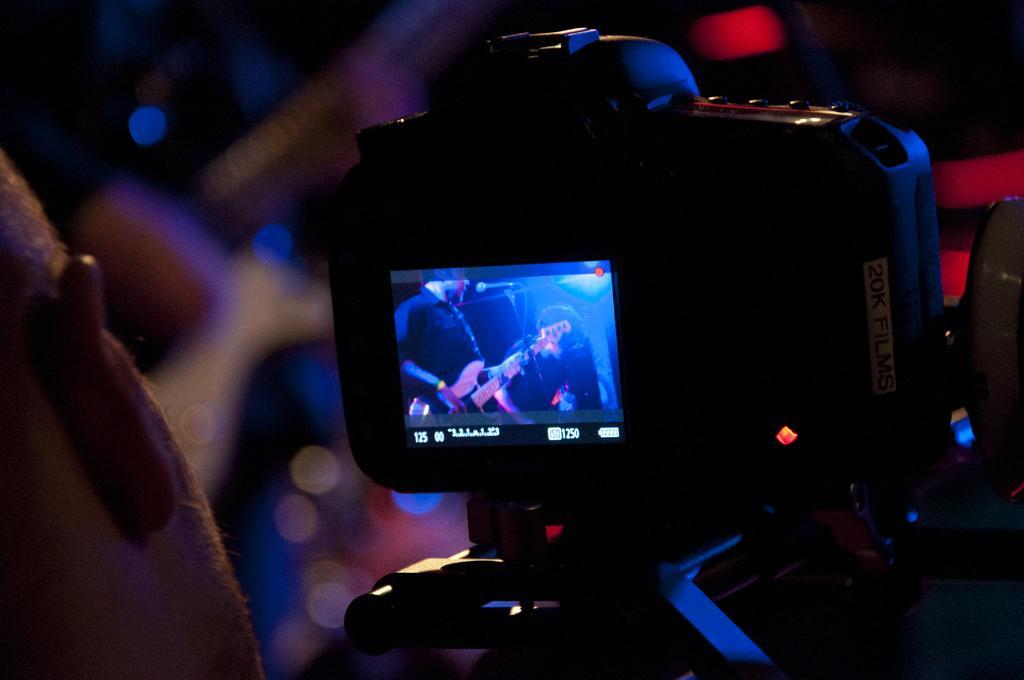In one or two sentences, can you explain what this image depicts? In this image we can see a person holding a camera placed on a stand. On the camera screen we can see a person with a guitar and a microphone placed in front of him. 